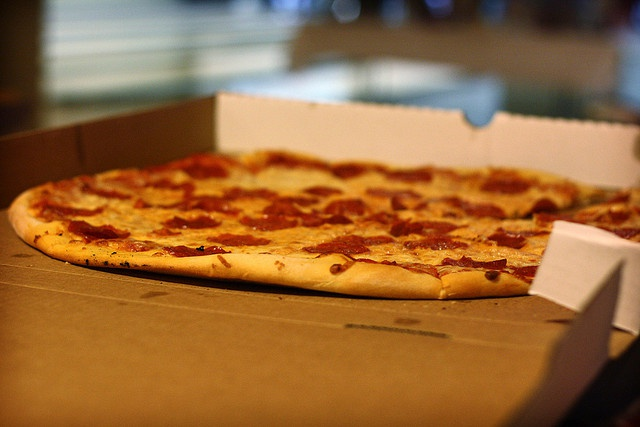Describe the objects in this image and their specific colors. I can see a pizza in black, orange, red, and maroon tones in this image. 